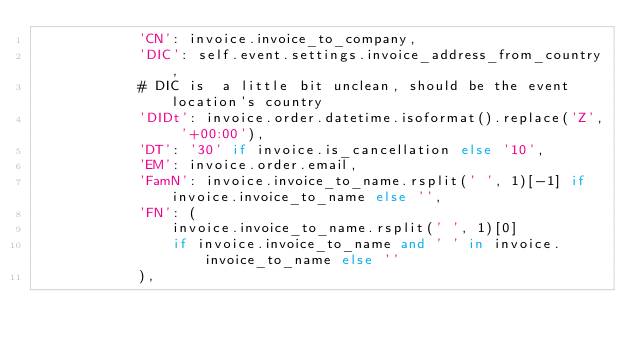Convert code to text. <code><loc_0><loc_0><loc_500><loc_500><_Python_>            'CN': invoice.invoice_to_company,
            'DIC': self.event.settings.invoice_address_from_country,
            # DIC is  a little bit unclean, should be the event location's country
            'DIDt': invoice.order.datetime.isoformat().replace('Z', '+00:00'),
            'DT': '30' if invoice.is_cancellation else '10',
            'EM': invoice.order.email,
            'FamN': invoice.invoice_to_name.rsplit(' ', 1)[-1] if invoice.invoice_to_name else '',
            'FN': (
                invoice.invoice_to_name.rsplit(' ', 1)[0]
                if invoice.invoice_to_name and ' ' in invoice.invoice_to_name else ''
            ),</code> 